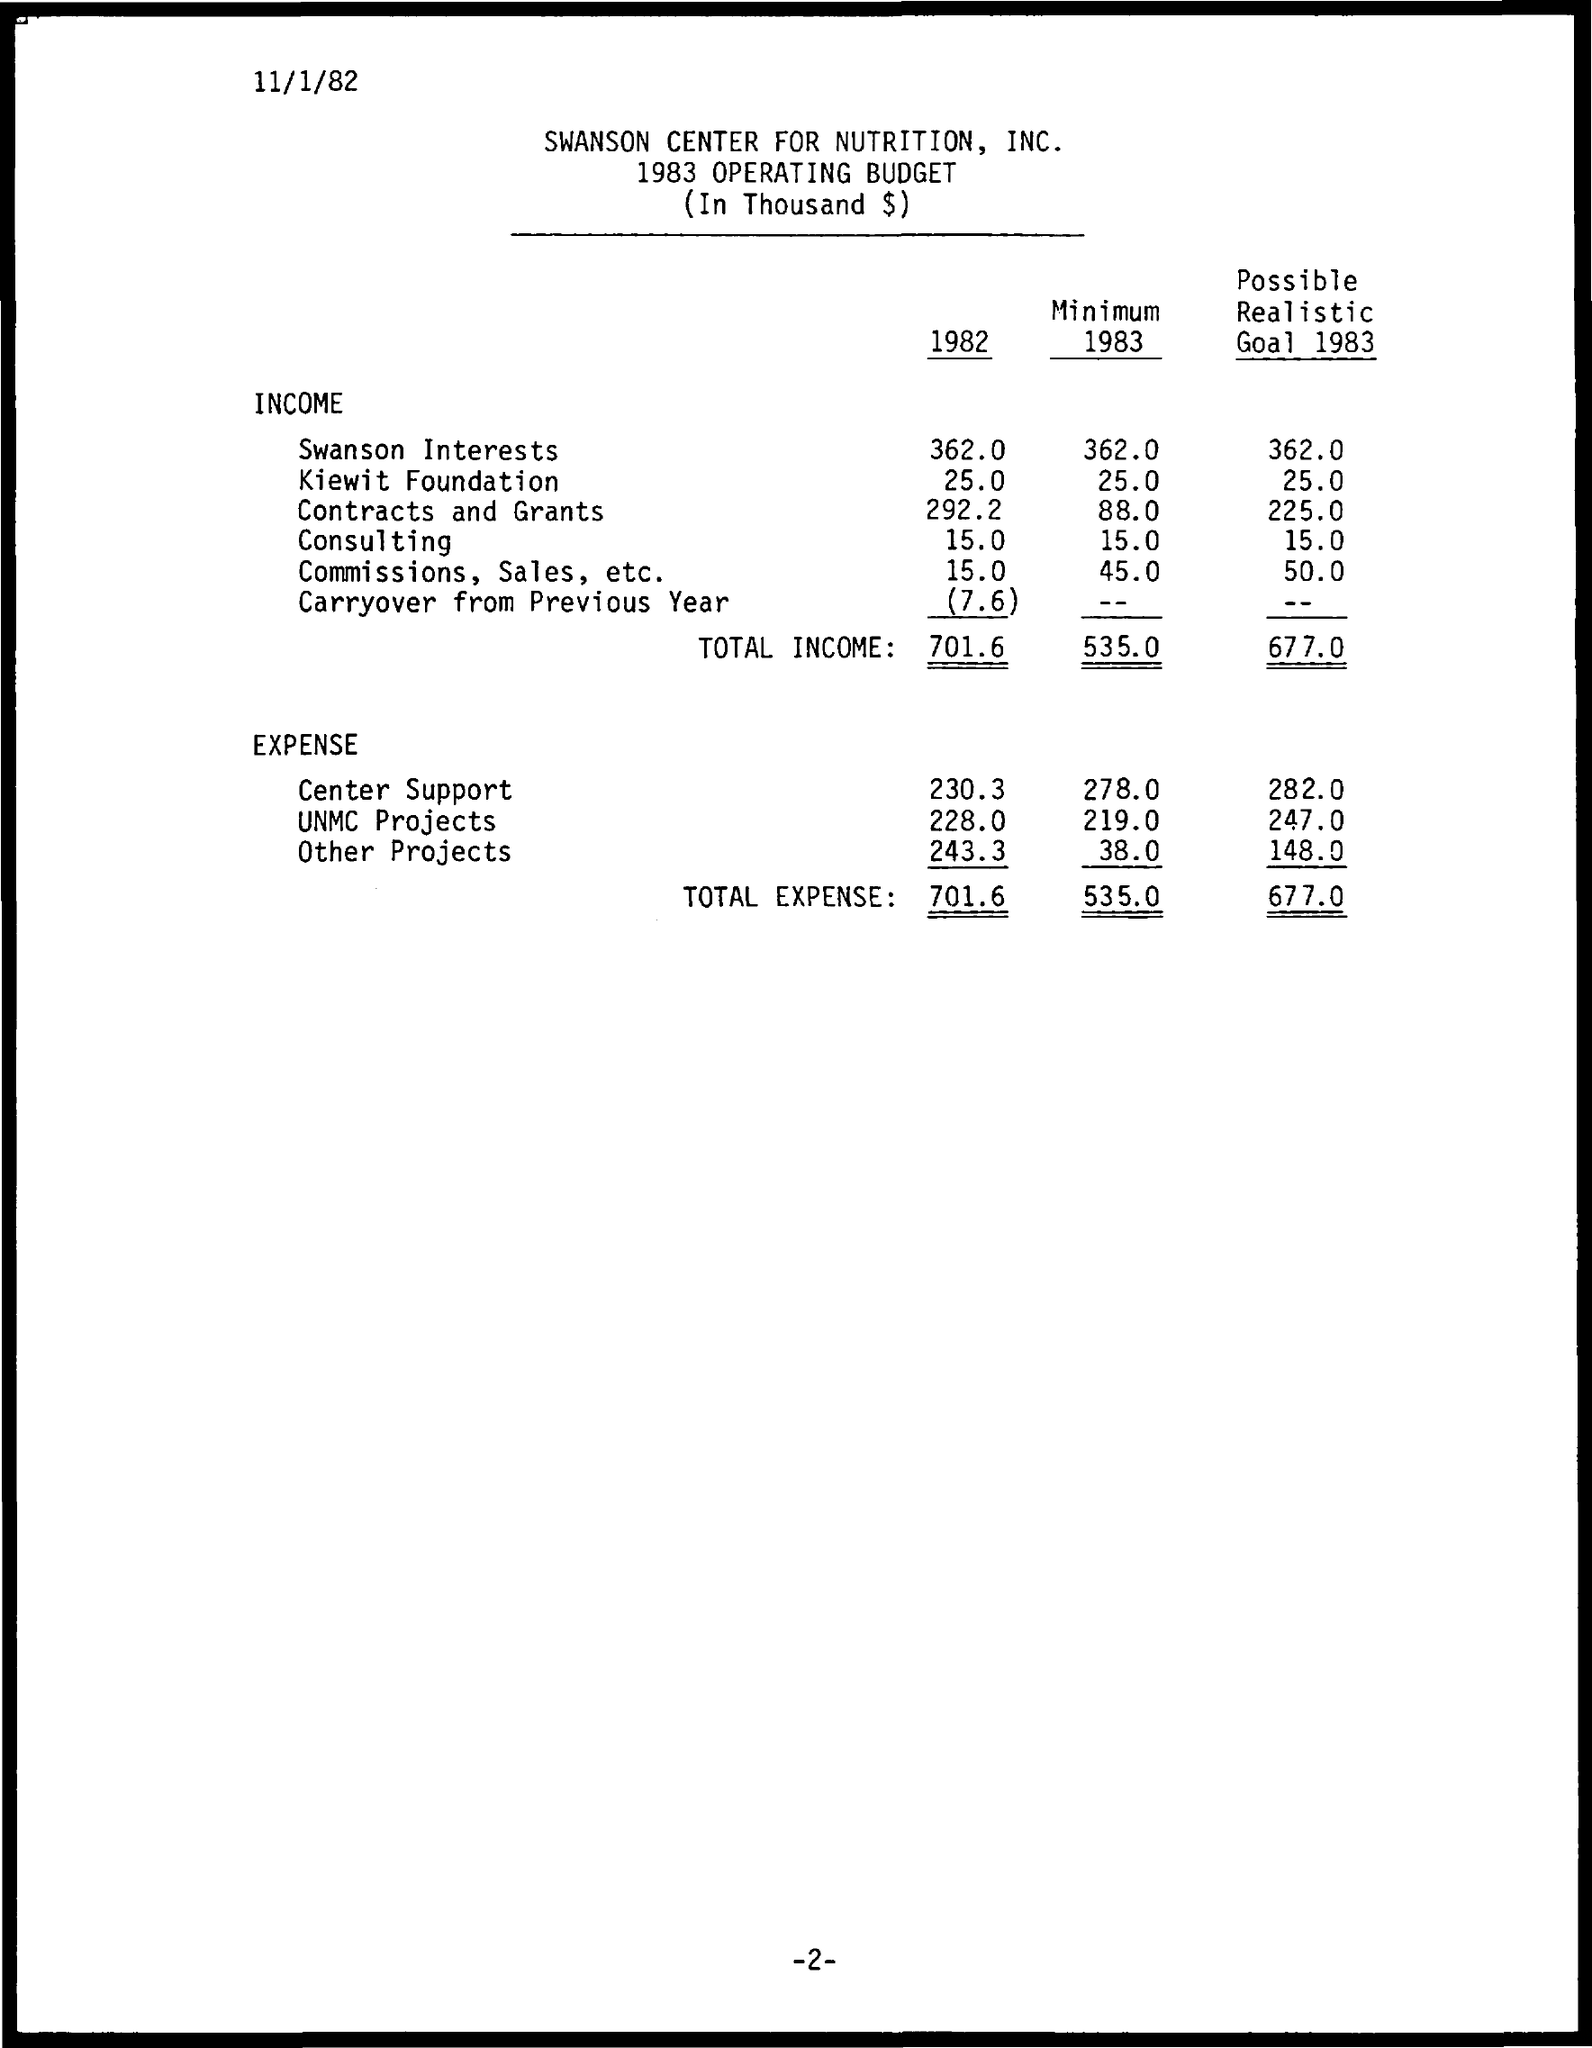Outline some significant characteristics in this image. The document is dated November 1, 1982. The document pertains to the 1983 operating budget. In the year 1982, the expense that was highest was Other Projects. 